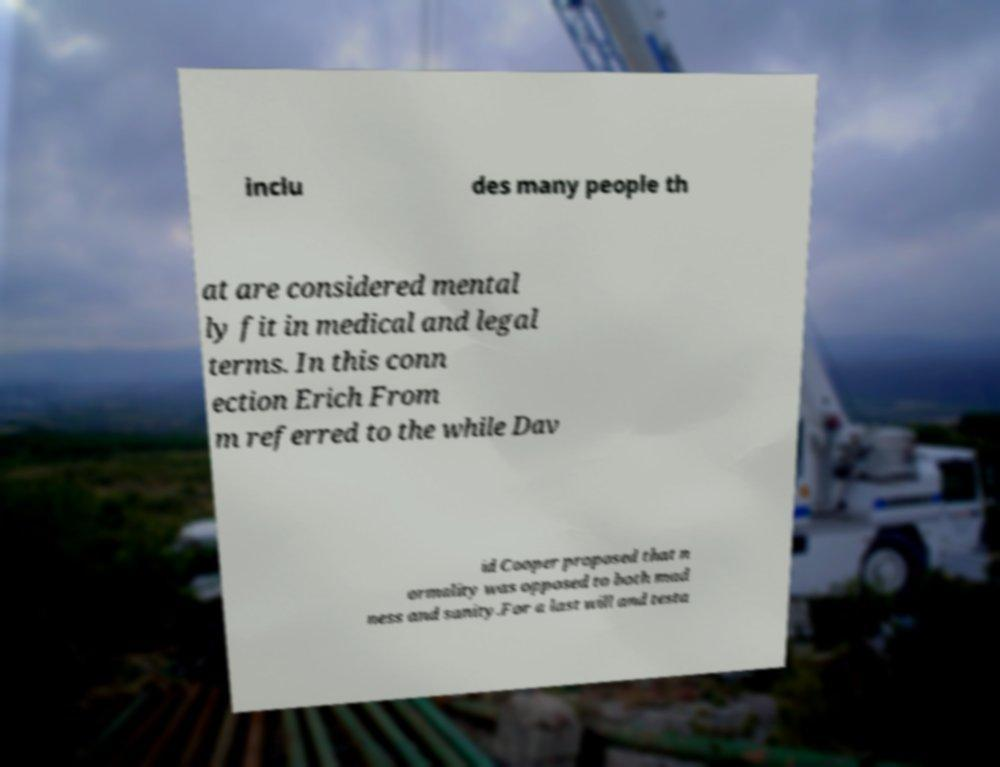Could you assist in decoding the text presented in this image and type it out clearly? inclu des many people th at are considered mental ly fit in medical and legal terms. In this conn ection Erich From m referred to the while Dav id Cooper proposed that n ormality was opposed to both mad ness and sanity.For a last will and testa 